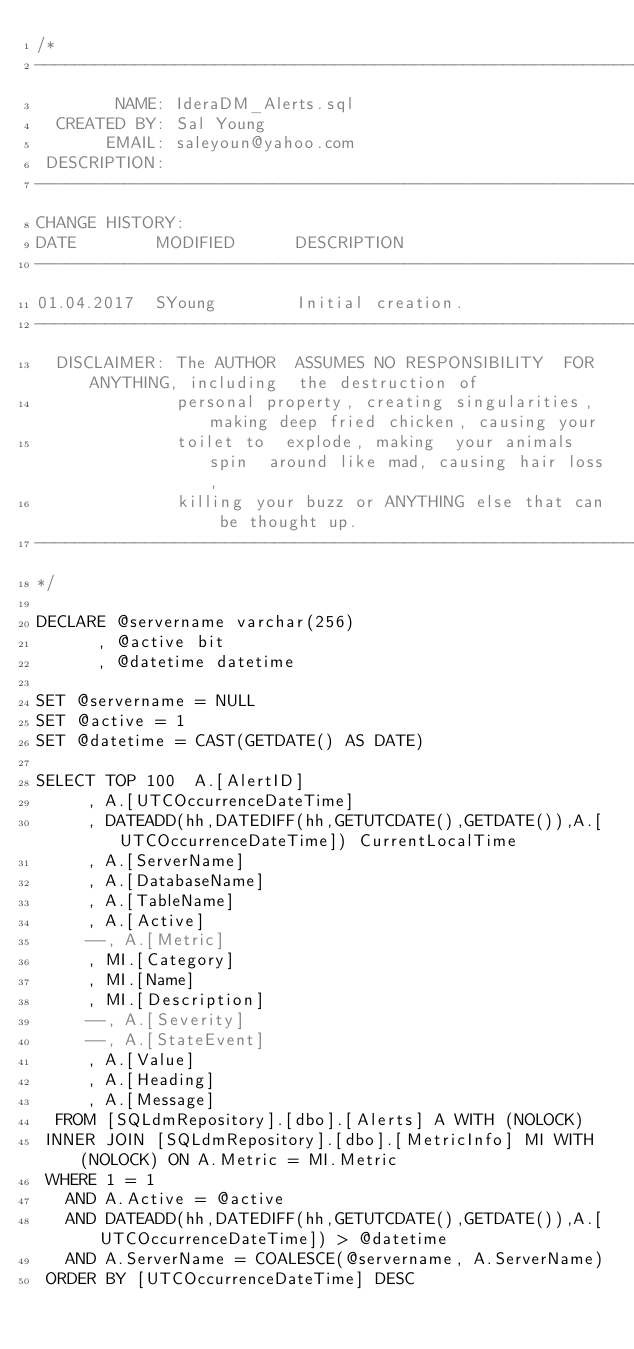<code> <loc_0><loc_0><loc_500><loc_500><_SQL_>/*
-------------------------------------------------------------------------------------------------
        NAME: IderaDM_Alerts.sql
  CREATED BY: Sal Young
       EMAIL: saleyoun@yahoo.com
 DESCRIPTION: 
-------------------------------------------------------------------------------------------------
CHANGE HISTORY:
DATE        MODIFIED      DESCRIPTION   
-------------------------------------------------------------------------------------------------
01.04.2017  SYoung        Initial creation.
-------------------------------------------------------------------------------------------------
  DISCLAIMER: The AUTHOR  ASSUMES NO RESPONSIBILITY  FOR ANYTHING, including  the destruction of 
              personal property, creating singularities, making deep fried chicken, causing your 
              toilet to  explode, making  your animals spin  around like mad, causing hair loss, 
              killing your buzz or ANYTHING else that can be thought up.
-------------------------------------------------------------------------------------------------
*/

DECLARE @servername varchar(256)
      , @active bit
      , @datetime datetime

SET @servername = NULL
SET @active = 1
SET @datetime = CAST(GETDATE() AS DATE)

SELECT TOP 100  A.[AlertID]
     , A.[UTCOccurrenceDateTime]
     , DATEADD(hh,DATEDIFF(hh,GETUTCDATE(),GETDATE()),A.[UTCOccurrenceDateTime]) CurrentLocalTime
     , A.[ServerName]
     , A.[DatabaseName]
     , A.[TableName]
     , A.[Active]
     --, A.[Metric]
     , MI.[Category]
     , MI.[Name]
     , MI.[Description]
     --, A.[Severity]
     --, A.[StateEvent]
     , A.[Value]
     , A.[Heading]
     , A.[Message]
  FROM [SQLdmRepository].[dbo].[Alerts] A WITH (NOLOCK)
 INNER JOIN [SQLdmRepository].[dbo].[MetricInfo] MI WITH (NOLOCK) ON A.Metric = MI.Metric
 WHERE 1 = 1
   AND A.Active = @active
   AND DATEADD(hh,DATEDIFF(hh,GETUTCDATE(),GETDATE()),A.[UTCOccurrenceDateTime]) > @datetime
   AND A.ServerName = COALESCE(@servername, A.ServerName)
 ORDER BY [UTCOccurrenceDateTime] DESC</code> 